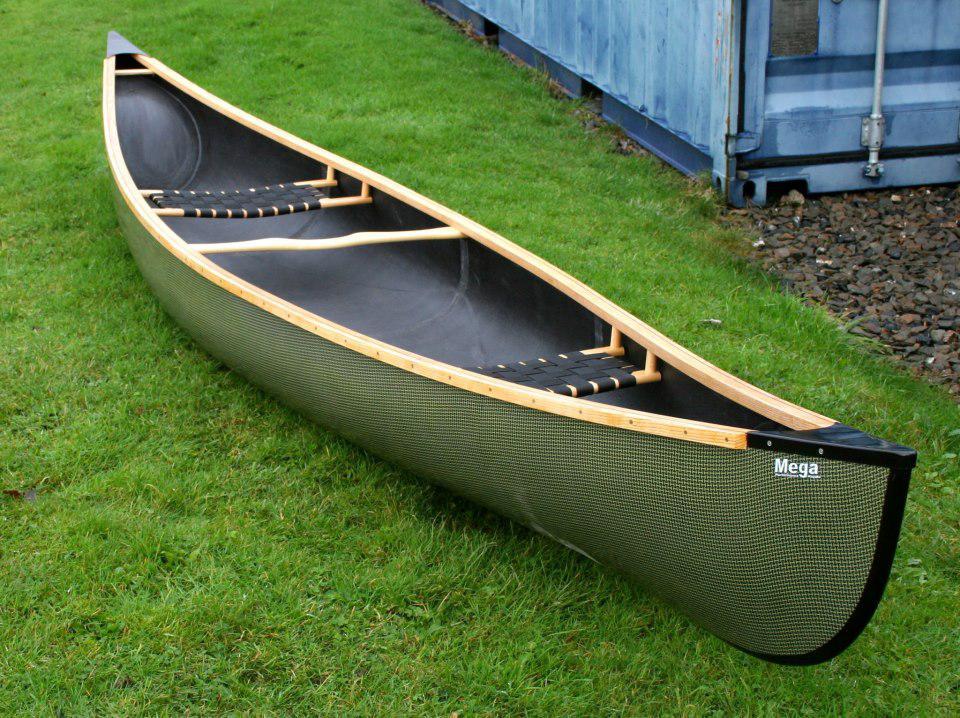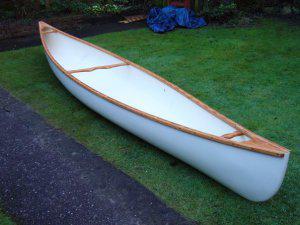The first image is the image on the left, the second image is the image on the right. Examine the images to the left and right. Is the description "Each image features an empty canoe sitting on green grass, and one image features a white canoe next to a strip of dark pavement, with a crumpled blue tarp behind it." accurate? Answer yes or no. Yes. 